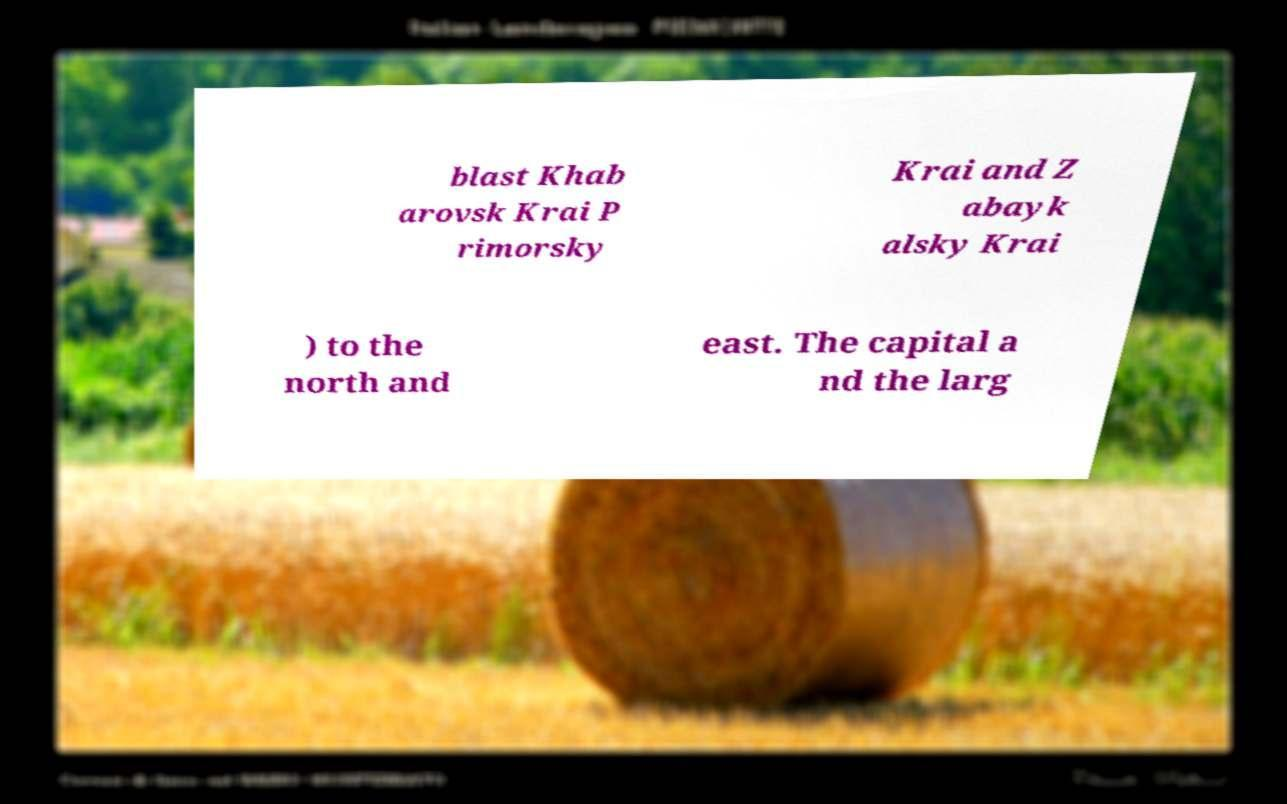Please read and relay the text visible in this image. What does it say? blast Khab arovsk Krai P rimorsky Krai and Z abayk alsky Krai ) to the north and east. The capital a nd the larg 